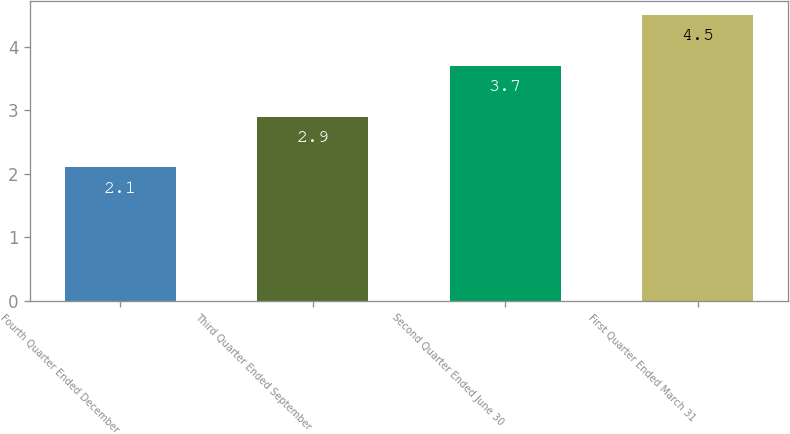<chart> <loc_0><loc_0><loc_500><loc_500><bar_chart><fcel>Fourth Quarter Ended December<fcel>Third Quarter Ended September<fcel>Second Quarter Ended June 30<fcel>First Quarter Ended March 31<nl><fcel>2.1<fcel>2.9<fcel>3.7<fcel>4.5<nl></chart> 